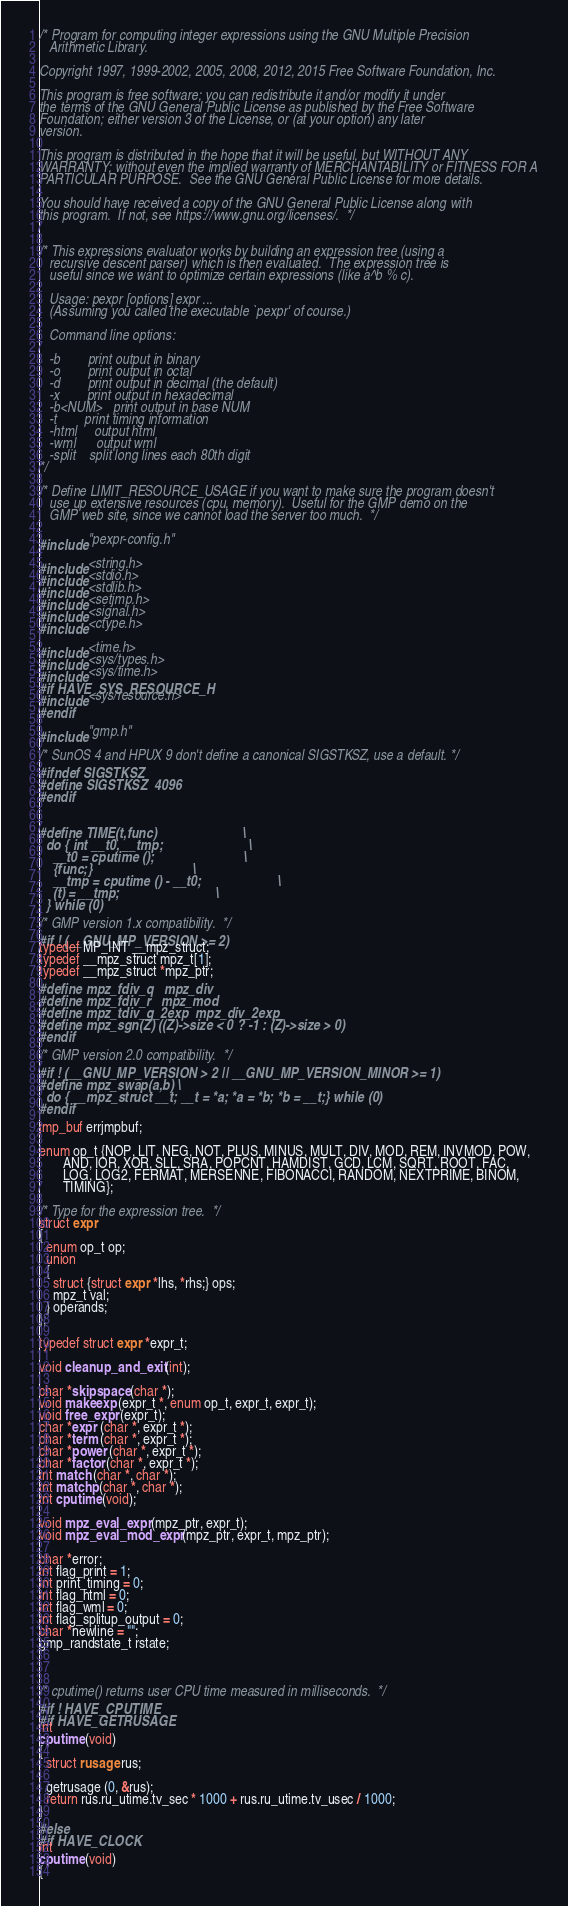<code> <loc_0><loc_0><loc_500><loc_500><_C_>/* Program for computing integer expressions using the GNU Multiple Precision
   Arithmetic Library.

Copyright 1997, 1999-2002, 2005, 2008, 2012, 2015 Free Software Foundation, Inc.

This program is free software; you can redistribute it and/or modify it under
the terms of the GNU General Public License as published by the Free Software
Foundation; either version 3 of the License, or (at your option) any later
version.

This program is distributed in the hope that it will be useful, but WITHOUT ANY
WARRANTY; without even the implied warranty of MERCHANTABILITY or FITNESS FOR A
PARTICULAR PURPOSE.  See the GNU General Public License for more details.

You should have received a copy of the GNU General Public License along with
this program.  If not, see https://www.gnu.org/licenses/.  */


/* This expressions evaluator works by building an expression tree (using a
   recursive descent parser) which is then evaluated.  The expression tree is
   useful since we want to optimize certain expressions (like a^b % c).

   Usage: pexpr [options] expr ...
   (Assuming you called the executable `pexpr' of course.)

   Command line options:

   -b        print output in binary
   -o        print output in octal
   -d        print output in decimal (the default)
   -x        print output in hexadecimal
   -b<NUM>   print output in base NUM
   -t        print timing information
   -html     output html
   -wml      output wml
   -split    split long lines each 80th digit
*/

/* Define LIMIT_RESOURCE_USAGE if you want to make sure the program doesn't
   use up extensive resources (cpu, memory).  Useful for the GMP demo on the
   GMP web site, since we cannot load the server too much.  */

#include "pexpr-config.h"

#include <string.h>
#include <stdio.h>
#include <stdlib.h>
#include <setjmp.h>
#include <signal.h>
#include <ctype.h>

#include <time.h>
#include <sys/types.h>
#include <sys/time.h>
#if HAVE_SYS_RESOURCE_H
#include <sys/resource.h>
#endif

#include "gmp.h"

/* SunOS 4 and HPUX 9 don't define a canonical SIGSTKSZ, use a default. */
#ifndef SIGSTKSZ
#define SIGSTKSZ  4096
#endif


#define TIME(t,func)							\
  do { int __t0, __tmp;							\
    __t0 = cputime ();							\
    {func;}								\
    __tmp = cputime () - __t0;						\
    (t) = __tmp;							\
  } while (0)

/* GMP version 1.x compatibility.  */
#if ! (__GNU_MP_VERSION >= 2)
typedef MP_INT __mpz_struct;
typedef __mpz_struct mpz_t[1];
typedef __mpz_struct *mpz_ptr;
#define mpz_fdiv_q	mpz_div
#define mpz_fdiv_r	mpz_mod
#define mpz_tdiv_q_2exp	mpz_div_2exp
#define mpz_sgn(Z) ((Z)->size < 0 ? -1 : (Z)->size > 0)
#endif

/* GMP version 2.0 compatibility.  */
#if ! (__GNU_MP_VERSION > 2 || __GNU_MP_VERSION_MINOR >= 1)
#define mpz_swap(a,b) \
  do { __mpz_struct __t; __t = *a; *a = *b; *b = __t;} while (0)
#endif

jmp_buf errjmpbuf;

enum op_t {NOP, LIT, NEG, NOT, PLUS, MINUS, MULT, DIV, MOD, REM, INVMOD, POW,
	   AND, IOR, XOR, SLL, SRA, POPCNT, HAMDIST, GCD, LCM, SQRT, ROOT, FAC,
	   LOG, LOG2, FERMAT, MERSENNE, FIBONACCI, RANDOM, NEXTPRIME, BINOM,
	   TIMING};

/* Type for the expression tree.  */
struct expr
{
  enum op_t op;
  union
  {
    struct {struct expr *lhs, *rhs;} ops;
    mpz_t val;
  } operands;
};

typedef struct expr *expr_t;

void cleanup_and_exit (int);

char *skipspace (char *);
void makeexp (expr_t *, enum op_t, expr_t, expr_t);
void free_expr (expr_t);
char *expr (char *, expr_t *);
char *term (char *, expr_t *);
char *power (char *, expr_t *);
char *factor (char *, expr_t *);
int match (char *, char *);
int matchp (char *, char *);
int cputime (void);

void mpz_eval_expr (mpz_ptr, expr_t);
void mpz_eval_mod_expr (mpz_ptr, expr_t, mpz_ptr);

char *error;
int flag_print = 1;
int print_timing = 0;
int flag_html = 0;
int flag_wml = 0;
int flag_splitup_output = 0;
char *newline = "";
gmp_randstate_t rstate;



/* cputime() returns user CPU time measured in milliseconds.  */
#if ! HAVE_CPUTIME
#if HAVE_GETRUSAGE
int
cputime (void)
{
  struct rusage rus;

  getrusage (0, &rus);
  return rus.ru_utime.tv_sec * 1000 + rus.ru_utime.tv_usec / 1000;
}
#else
#if HAVE_CLOCK
int
cputime (void)
{</code> 